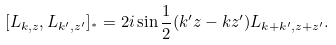Convert formula to latex. <formula><loc_0><loc_0><loc_500><loc_500>[ L _ { k , z } , L _ { k ^ { \prime } , z ^ { \prime } } ] _ { ^ { * } } = 2 i \sin \frac { 1 } { 2 } ( k ^ { \prime } z - k z ^ { \prime } ) L _ { k + k ^ { \prime } , z + z ^ { \prime } } .</formula> 